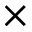Convert formula to latex. <formula><loc_0><loc_0><loc_500><loc_500>\times</formula> 